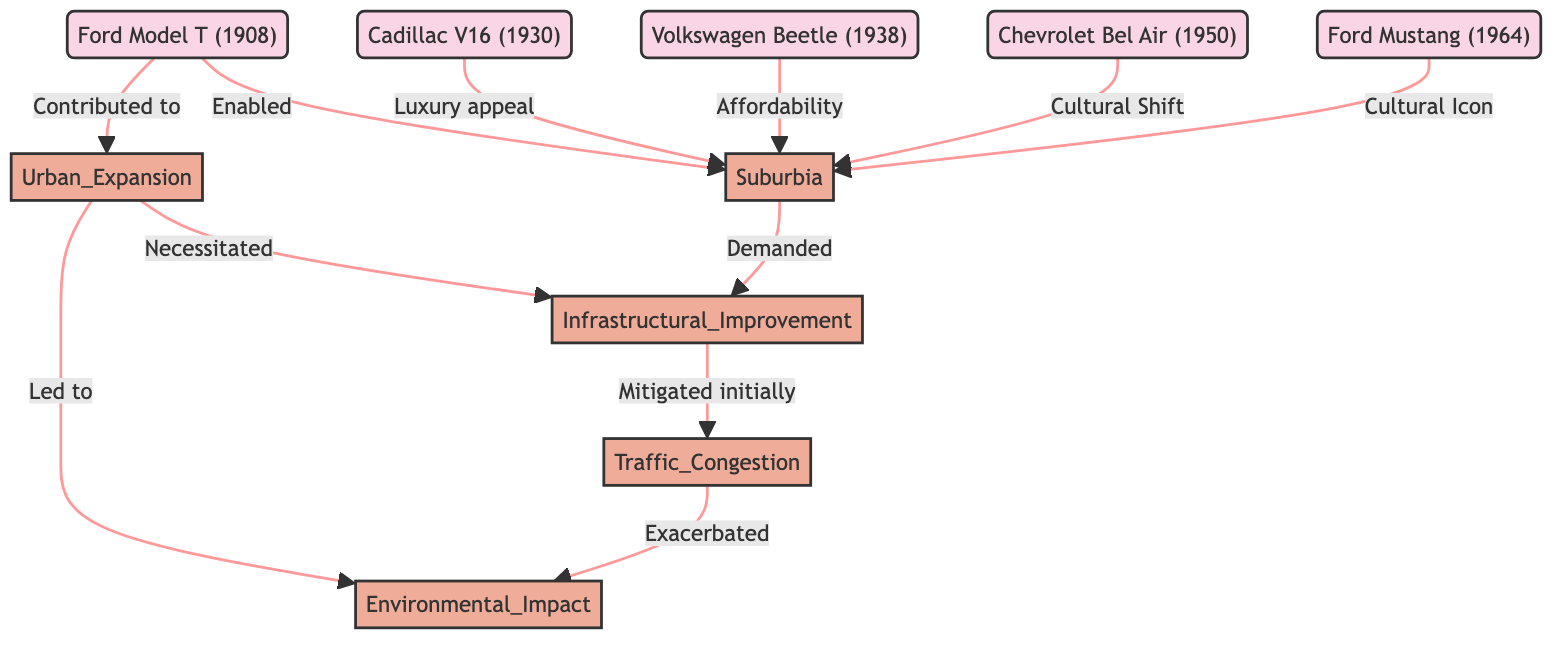What is the first affordable automobile mentioned? The diagram shows the Ford Model T (1908) as the first affordable automobile, with a direct label indicating its accessibility to the general public.
Answer: Ford Model T (1908) How many automobile models are directly connected to Suburbia? By reviewing the edges in the diagram, there are four automobile models (Cadillac V16, Volkswagen Beetle, Chevrolet Bel Air, Ford Mustang) connected to Suburbia, indicating their influence on suburban development.
Answer: 4 What did Urban Expansion necessitate? The diagram illustrates that Urban Expansion required Infrastructural Improvement, as indicated by the edge labeled "Necessitated."
Answer: Infrastructural Improvement Which automobile model is linked to traffic congestion mitigation initially? According to the diagram, the Infrastructural Improvement node has a directed edge towards Traffic Congestion, labeled as "Mitigated initially," indicating this relationship.
Answer: Infrastructural Improvement What environmental consequence is exacerbated by Traffic Congestion? The diagram shows a directed edge from Traffic Congestion to Environmental Impact, denoted as "Exacerbated," indicating this negative relationship.
Answer: Environmental Impact What was the trend in urban development as a result of mass automobile usage? The diagram connects Urban Expansion to Environmental Impact with the label "Led to," indicating that the trend was an increase in environmental challenges due to more cars on the road.
Answer: Environmental Impact What type of vehicle did the Chevy Bel Air symbolize? The diagram specifically notes that the Chevrolet Bel Air represented a cultural shift, linking it to the social changes in the 1950s.
Answer: Cultural Shift How is the Volkswagen Beetle associated with suburban development? The diagram indicates that the Volkswagen Beetle contributed to suburban development through its affordability, which is explicitly stated in the directed edge leading to Suburbia.
Answer: Affordability 